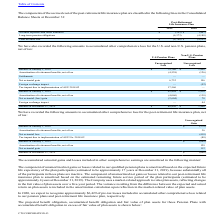According to Cts Corporation's financial document, What was the balance of Unrecognized loss for U.S. Pension Plans in 2018? According to the financial document, 75,740 (in thousands). The relevant text states: "Balance at January 1, 2018 $ 75,740 $ 1,898..." Also, What was the unrecognized loss for Net actuarial gain for Non-U.S. Pension Plans? According to the financial document, 196 (in thousands). The relevant text states: "Net actuarial gain 6,732 196..." Also, What was the balance of Amortization of retirement benefits, net of tax for Non-U.S. Pension Plans? According to the financial document, (138) (in thousands). The relevant text states: "ization of retirement benefits, net of tax (4,060) (138)..." Also, can you calculate: What was the difference in the balance at December 31, 2019 for Unrecognized losses between U.S and Non-U.S. Pension Plans? Based on the calculation: 88,830-1,900, the result is 86930 (in thousands). This is based on the information: "Balance at December 31, 2019 $ 88,830 $ 1,900 Balance at December 31, 2019 $ 88,830 $ 1,900..." The key data points involved are: 1,900, 88,830. Also, can you calculate: What was the difference between the Amortization of retirement benefits, net of tax between U.S. and Non-U.S. Pension Plans in 2019? Based on the calculation: -4,060-(-138), the result is -3922 (in thousands). This is based on the information: "Amortization of retirement benefits, net of tax (4,060) (138) ation of retirement benefits, net of tax (4,060) (138)..." The key data points involved are: 138, 4,060. Also, can you calculate: What was the percentage change in the balance for unrecognized losses for U.S. Pension Plans between January 1, 2018 and 2019? To answer this question, I need to perform calculations using the financial data. The calculation is: (95,494-75,740)/75,740, which equals 26.08 (percentage). This is based on the information: "Balance at January 1, 2019 $ 95,494 $ 1,916 Balance at January 1, 2018 $ 75,740 $ 1,898..." The key data points involved are: 75,740, 95,494. 